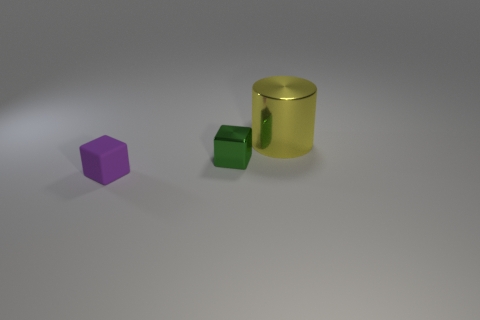Are there any other things that have the same material as the purple cube?
Provide a succinct answer. No. How many objects are green spheres or tiny blocks?
Provide a short and direct response. 2. How many small blocks are right of the small block behind the tiny matte thing?
Provide a succinct answer. 0. How many other objects are there of the same size as the purple matte object?
Offer a very short reply. 1. Do the tiny thing that is behind the purple matte block and the small matte thing have the same shape?
Your answer should be compact. Yes. What material is the object that is right of the metallic block?
Make the answer very short. Metal. Is there a big brown thing made of the same material as the small green cube?
Offer a very short reply. No. How big is the yellow metallic cylinder?
Your answer should be compact. Large. How many brown things are small objects or small shiny cubes?
Your response must be concise. 0. How many other things have the same shape as the purple object?
Provide a succinct answer. 1. 